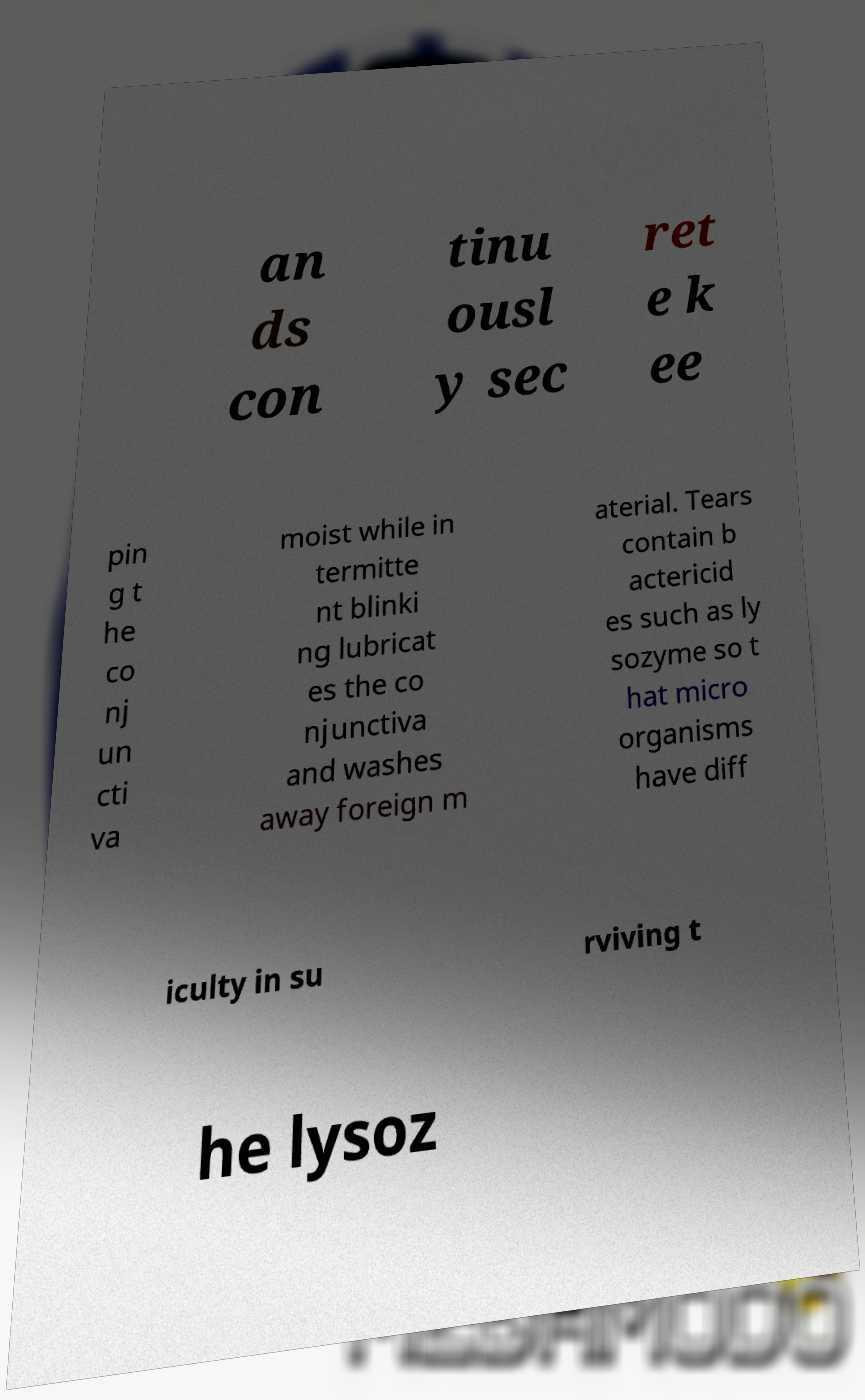What messages or text are displayed in this image? I need them in a readable, typed format. an ds con tinu ousl y sec ret e k ee pin g t he co nj un cti va moist while in termitte nt blinki ng lubricat es the co njunctiva and washes away foreign m aterial. Tears contain b actericid es such as ly sozyme so t hat micro organisms have diff iculty in su rviving t he lysoz 